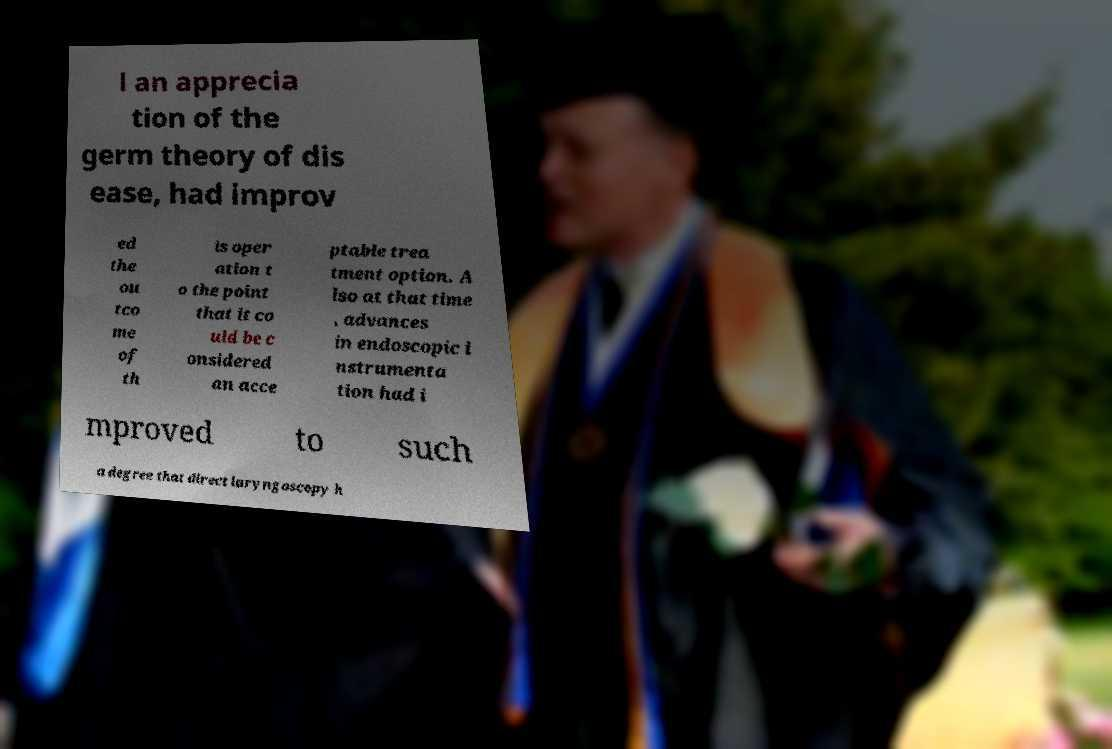For documentation purposes, I need the text within this image transcribed. Could you provide that? l an apprecia tion of the germ theory of dis ease, had improv ed the ou tco me of th is oper ation t o the point that it co uld be c onsidered an acce ptable trea tment option. A lso at that time , advances in endoscopic i nstrumenta tion had i mproved to such a degree that direct laryngoscopy h 